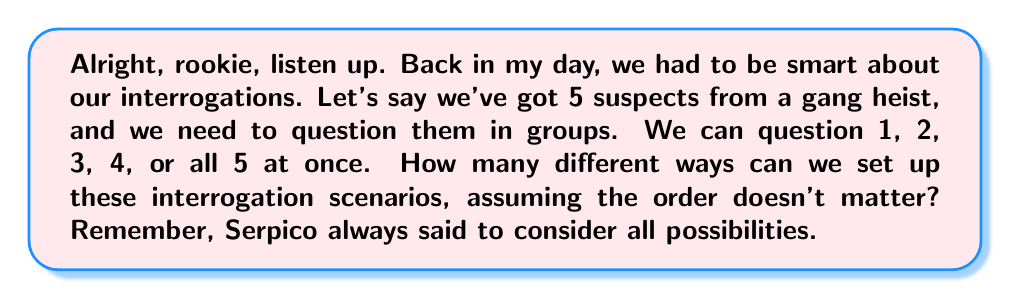Help me with this question. Let's break this down step-by-step, just like we'd crack a case:

1) First, we need to consider all possible group sizes: 1, 2, 3, 4, and 5 suspects.

2) For each group size, we need to calculate the number of possible combinations:

   - For groups of 1: We use the combination formula $\binom{5}{1}$
   - For groups of 2: $\binom{5}{2}$
   - For groups of 3: $\binom{5}{3}$
   - For groups of 4: $\binom{5}{4}$
   - For groups of 5: $\binom{5}{5}$

3) Let's calculate each of these:

   $$\binom{5}{1} = \frac{5!}{1!(5-1)!} = 5$$
   $$\binom{5}{2} = \frac{5!}{2!(5-2)!} = 10$$
   $$\binom{5}{3} = \frac{5!}{3!(5-3)!} = 10$$
   $$\binom{5}{4} = \frac{5!}{4!(5-4)!} = 5$$
   $$\binom{5}{5} = \frac{5!}{5!(5-5)!} = 1$$

4) Now, we sum up all these possibilities:

   $$5 + 10 + 10 + 5 + 1 = 31$$

This gives us the total number of different interrogation scenarios we can set up with these 5 suspects.
Answer: 31 different interrogation scenarios 